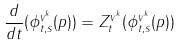<formula> <loc_0><loc_0><loc_500><loc_500>\frac { d } { d t } ( \phi _ { t , s } ^ { v ^ { k } } ( p ) ) = Z _ { t } ^ { v ^ { k } } ( \phi _ { t , s } ^ { v ^ { k } } ( p ) )</formula> 